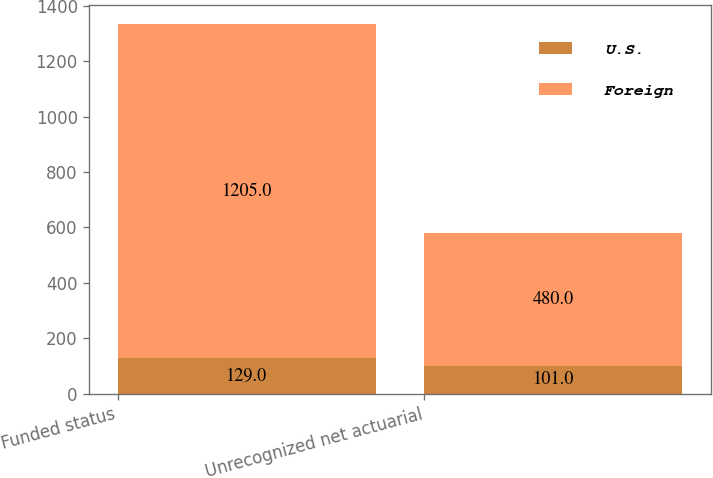<chart> <loc_0><loc_0><loc_500><loc_500><stacked_bar_chart><ecel><fcel>Funded status<fcel>Unrecognized net actuarial<nl><fcel>U.S.<fcel>129<fcel>101<nl><fcel>Foreign<fcel>1205<fcel>480<nl></chart> 